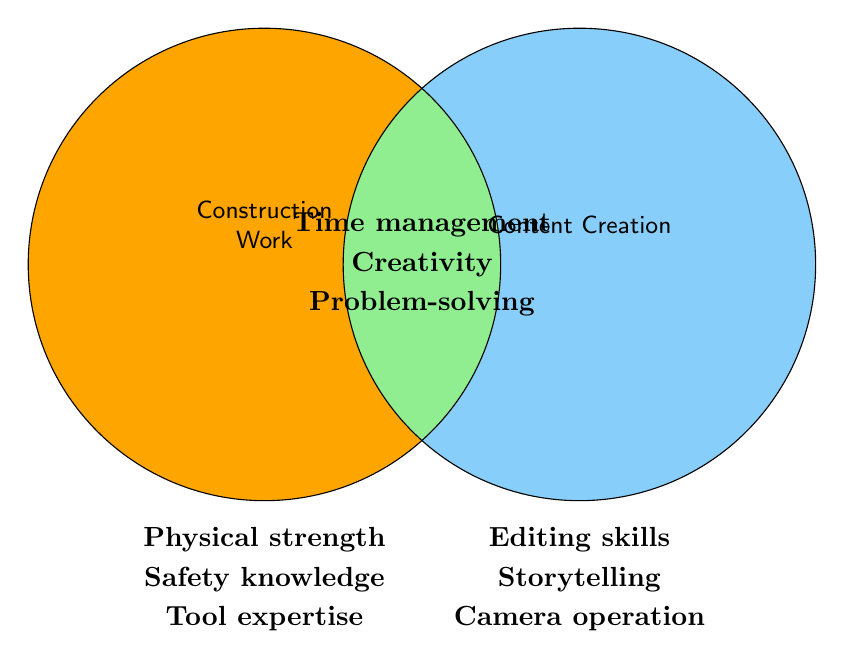What's listed on the left circle? The left circle represents construction work, and the skills listed there are Physical strength, Safety knowledge, and Tool expertise.
Answer: Physical strength, Safety knowledge, Tool expertise What's listed on the right circle? The right circle represents content creation, and the skills listed there are Editing skills, Storytelling, and Camera operation.
Answer: Editing skills, Storytelling, Camera operation What skills overlap between construction work and content creation? The overlapping skills are those in the intersection of the two circles. These skills are Time management, Creativity, and Problem-solving.
Answer: Time management, Creativity, Problem-solving Which skill is in construction work but not in content creation? The skills that are specific to construction work and not in content creation are found solely in the left circle. These are Physical strength, Safety knowledge, and Tool expertise.
Answer: Physical strength, Safety knowledge, Tool expertise Which skill is in content creation but not in construction work? The skills that are exclusive to content creation and not in construction work are found solely in the right circle. These are Editing skills, Storytelling, and Camera operation.
Answer: Editing skills, Storytelling, Camera operation Are there more skills uniquely in construction work or in content creation? To determine this, compare the number of unique skills in each circle. Construction work has 3 unique skills, and content creation also has 3 unique skills.
Answer: Equal How many skills are shown in total? Count all the skills in the Venn Diagram, including those in the overlapping area. There are 6 skills unique to each domain (3 in each) and 3 overlapping skills, totaling 9 skills.
Answer: 9 Name any two overlapping skills. To find two overlapping skills, look at the intersection of the circles. Possible answers are Time management, Creativity, and Problem-solving.
Answer: Time management, Creativity Which category includes Tool expertise? Tool expertise is listed under construction work which is represented by the left circle.
Answer: Construction work 